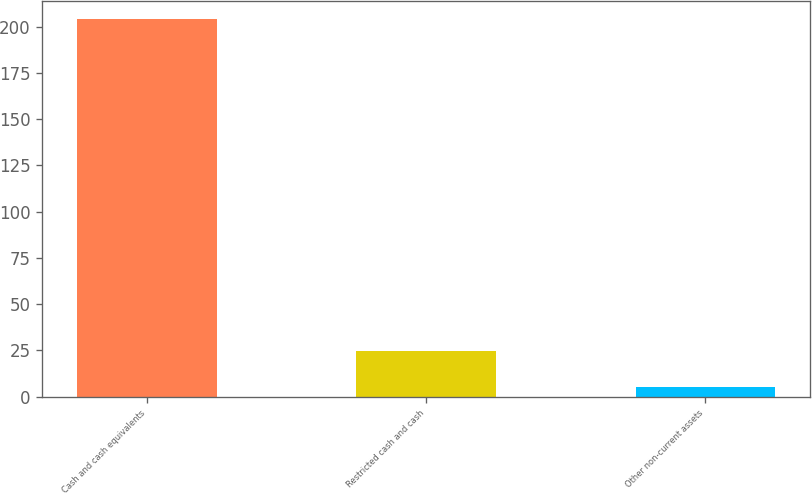<chart> <loc_0><loc_0><loc_500><loc_500><bar_chart><fcel>Cash and cash equivalents<fcel>Restricted cash and cash<fcel>Other non-current assets<nl><fcel>204<fcel>24.9<fcel>5<nl></chart> 